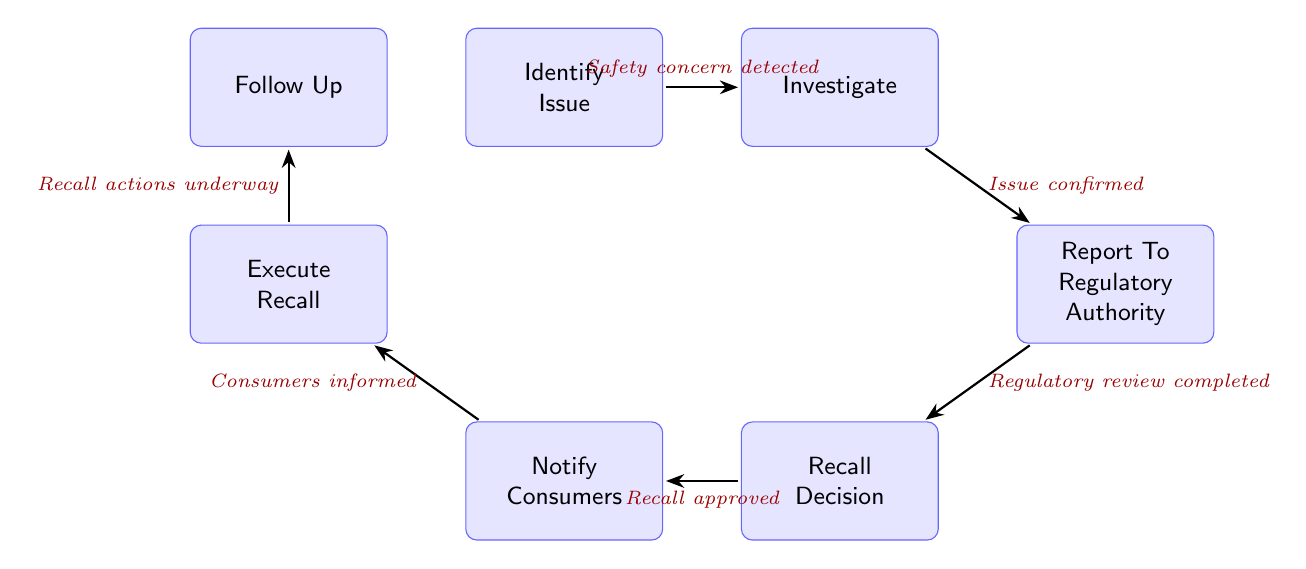What is the first state in the process? The diagram begins with the state labeled "Identify Issue," which signifies the detection of a potential safety issue. This is the first node in the sequence of states.
Answer: Identify Issue How many states are in this diagram? The diagram displays a total of 7 states representing different phases of the product recall process. By counting each state listed, we arrive at this total.
Answer: 7 What is the last state of the process? The final state in the diagram is "Follow Up," which indicates the conclusion of the recall process where the effectiveness is monitored and updates are provided.
Answer: Follow Up What condition must be met to transition from "Investigate" to "Report To Regulatory Authority"? The transition from "Investigate" to "Report To Regulatory Authority" occurs when the condition "Issue confirmed" is satisfied, indicating that the safety issue has been verified.
Answer: Issue confirmed Which state follows "Notify Consumers"? After the state "Notify Consumers," the process moves to "Execute Recall." This transition occurs when consumers have been informed of the safety issue.
Answer: Execute Recall What is the relationship between "Report To Regulatory Authority" and "Recall Decision"? The state "Report To Regulatory Authority" leads to "Recall Decision" when the condition "Regulatory review completed" is met. This indicates that after reporting, a decision regarding the recall is made.
Answer: Regulatory review completed In how many steps can the recall process be executed from the first to the last state? Starting from "Identify Issue" to "Follow Up," the entire recall process consists of 6 steps, as each transition from state to state counts toward this total.
Answer: 6 What condition is required to move from "Recall Decision" to "Notify Consumers"? The transition from "Recall Decision" to "Notify Consumers" is contingent upon the condition "Recall approved," which indicates that the decision to recall the product has been authorized.
Answer: Recall approved 